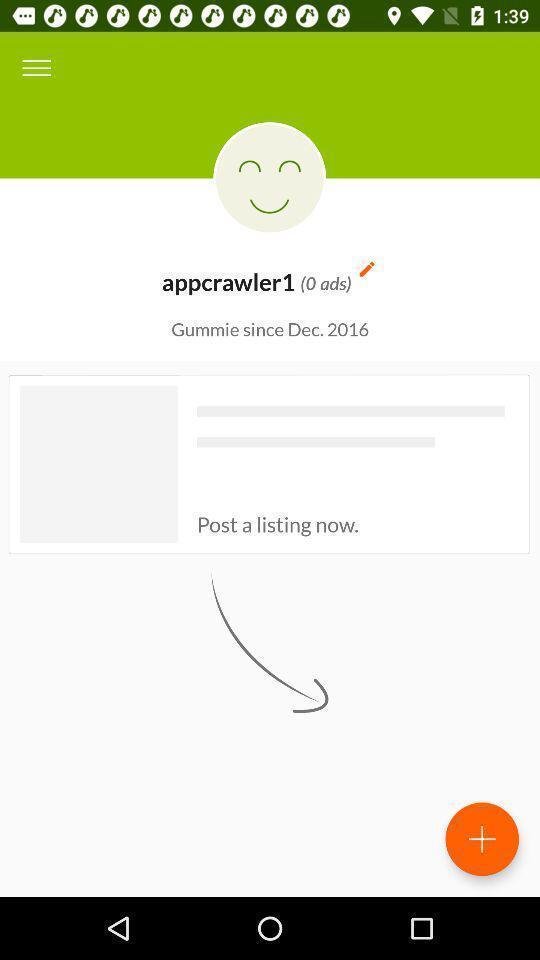Summarize the information in this screenshot. Screen showing profile page in a social app. 